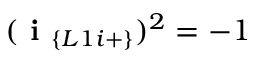Convert formula to latex. <formula><loc_0><loc_0><loc_500><loc_500>( i _ { \{ L 1 i + \} } ) ^ { 2 } = - 1</formula> 